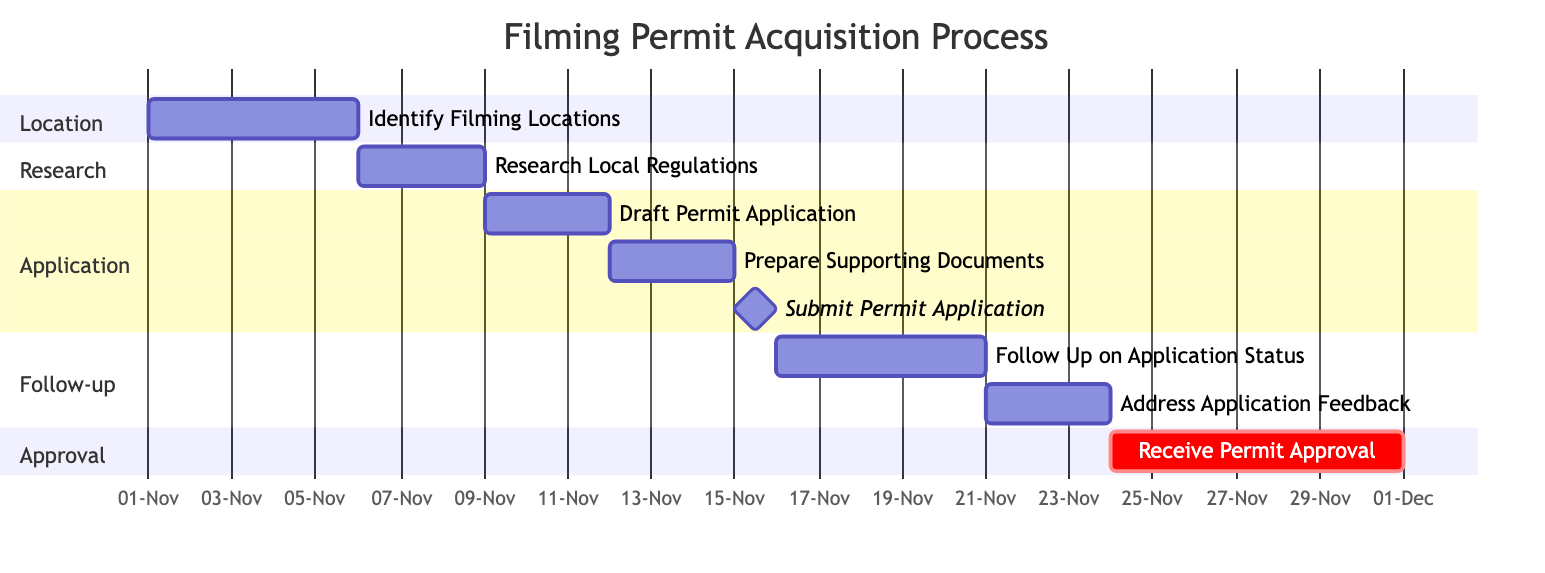What is the duration of the task "Identify Filming Locations"? The task "Identify Filming Locations" starts on November 1, 2023, and ends on November 5, 2023. The duration can be calculated as the end date minus the start date (5 days).
Answer: 5 days How many tasks are in the "Application" section? By looking at the "Application" section, we see three tasks listed: "Draft Permit Application," "Prepare Supporting Documents," and "Submit Permit Application." This gives a total of three tasks.
Answer: 3 tasks What day does the "Submit Permit Application" task occur? The "Submit Permit Application" task is marked as a milestone and occurs on a single day, November 15, 2023, as per the diagram.
Answer: November 15, 2023 What is the total duration from the start of the "Follow Up on Application Status" to the end of the "Receive Permit Approval"? The "Follow Up on Application Status" starts on November 16, 2023, and "Receive Permit Approval" ends on November 30, 2023. The duration can be calculated as the end date minus the start date plus one day. The total duration is 15 days.
Answer: 15 days Which task directly follows "Prepare Supporting Documents"? The task that directly follows "Prepare Supporting Documents" is "Submit Permit Application," which occurs immediately after this task as indicated in the diagram, occurring on November 15, 2023.
Answer: Submit Permit Application What task starts immediately after "Address Application Feedback"? The task that follows "Address Application Feedback," according to the timeline, is "Receive Permit Approval," which starts on November 24, 2023.
Answer: Receive Permit Approval What is the total number of tasks depicted in the Gantt chart? By counting each task listed in the Gantt Chart, there are eight tasks in total: "Identify Filming Locations," "Research Local Regulations," "Draft Permit Application," "Prepare Supporting Documents," "Submit Permit Application," "Follow Up on Application Status," "Address Application Feedback," and "Receive Permit Approval."
Answer: 8 tasks What is the earliest start date for any task in the Gantt chart? Looking at all the tasks in the Gantt chart, the earliest start date is November 1, 2023, which is the start date for the "Identify Filming Locations" task.
Answer: November 1, 2023 